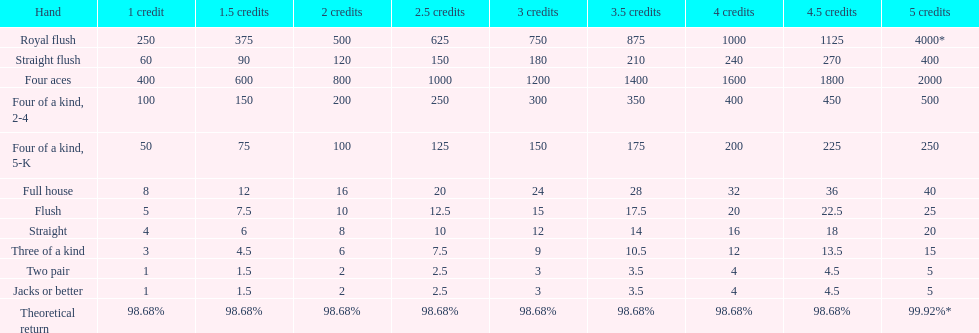What is the difference of payout on 3 credits, between a straight flush and royal flush? 570. 